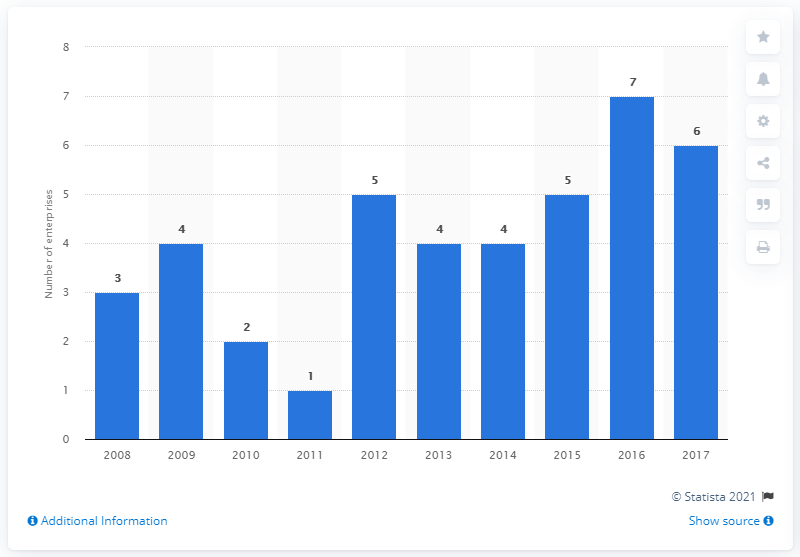Give some essential details in this illustration. In 2016, there were the most enterprises. The average of the two modes is 4.5. 